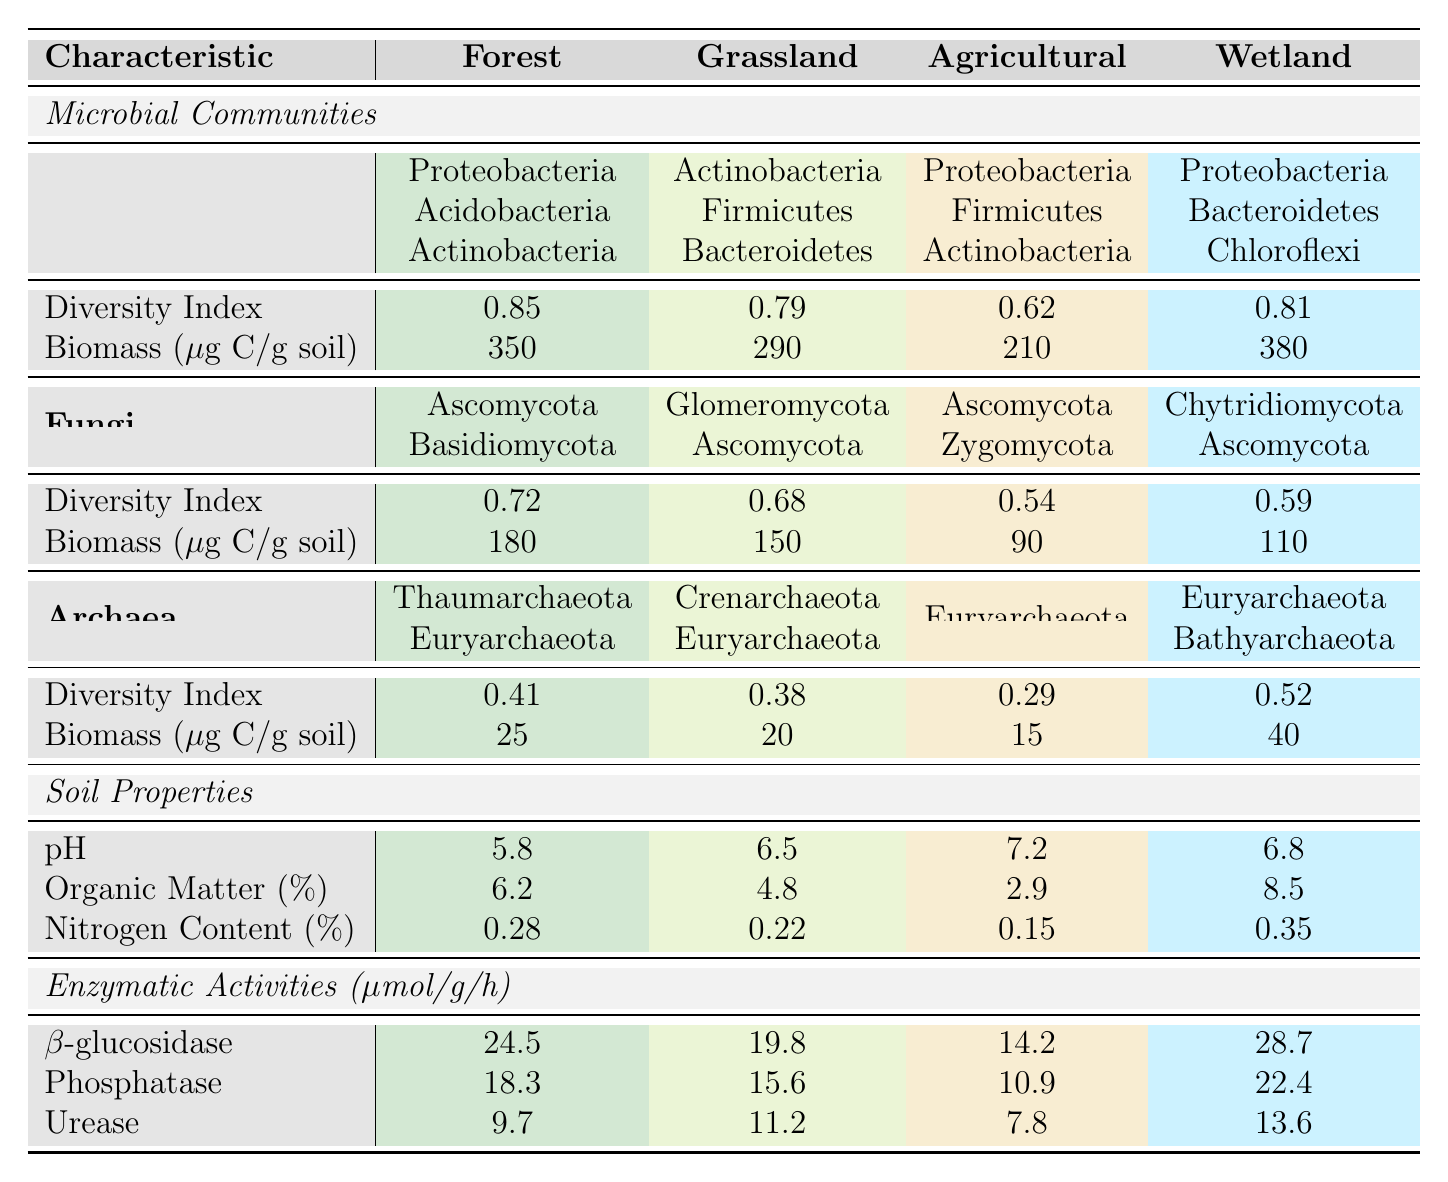What are the dominant bacterial phyla in forest land-use type? The table shows that the dominant bacterial phyla in the forest land-use type are Proteobacteria, Acidobacteria, and Actinobacteria.
Answer: Proteobacteria, Acidobacteria, Actinobacteria Which land-use type has the highest biomass of bacteria? In the table, the biomass for bacteria in various land-use types is shown. The forest has 350 μg C/g soil, grassland has 290 μg C/g soil, agricultural has 210 μg C/g soil, and wetland has 380 μg C/g soil. The wetland has the highest biomass of bacteria at 380 μg C/g soil.
Answer: Wetland What is the diversity index of fungi in agricultural land-use? Looking at the fungi section for agricultural land-use type, the diversity index is specified as 0.54.
Answer: 0.54 How does the average nitrogen content of forest land compare to that of agricultural land? The nitrogen content in forest land-use is 0.28% and in agricultural land-use is 0.15%. The average nitrogen content of forest land (0.28%) is higher than that of agricultural land (0.15%).
Answer: Higher What is the total enzymatic activity for β-glucosidase across all land-use types? The table provides the β-glucosidase activity as follows: Forest: 24.5; Grassland: 19.8; Agricultural: 14.2; Wetland: 28.7. Adding these values gives: 24.5 + 19.8 + 14.2 + 28.7 = 87.2 μmol/g/h.
Answer: 87.2 μmol/g/h Which land-use type has the lowest diversity index for archaea? The table indicates the diversity index for archaea: Forest: 0.41; Grassland: 0.38; Agricultural: 0.29; Wetland: 0.52. The agricultural land-use type has the lowest diversity index at 0.29.
Answer: Agricultural If we average the organic matter percentages across all land-use types, what is the result? The organic matter percentages are: Forest: 6.2%, Grassland: 4.8%, Agricultural: 2.9%, Wetland: 8.5%. Adding these gives a total of 6.2 + 4.8 + 2.9 + 8.5 = 22.4%. Dividing by 4 gives an average of 5.6%.
Answer: 5.6% Is the pH of grassland land-use type higher than that of wetland? The pH values from the table are: Forest: 5.8, Grassland: 6.5, Agricultural: 7.2, Wetland: 6.8. Comparing, the grassland (6.5) is not higher than the wetland (6.8). Therefore, the statement is false.
Answer: No What are the dominant fungal phyla in grassland? In the grassland land-use type, the dominant fungal phyla listed are Glomeromycota and Ascomycota, as per the table.
Answer: Glomeromycota, Ascomycota How much higher is the urease activity in wetland compared to agricultural land-use? Urease activities stated in the table are: Wetland: 13.6 μmol/g/h and Agricultural: 7.8 μmol/g/h. The difference is calculated as 13.6 - 7.8 = 5.8 μmol/g/h.
Answer: 5.8 μmol/g/h What is the average diversity index for bacteria across all land-use types? The diversity indices for bacteria are: Forest: 0.85, Grassland: 0.79, Agricultural: 0.62, Wetland: 0.81. Summing these gives 0.85 + 0.79 + 0.62 + 0.81 = 3.07. Dividing by 4 gives an average of 0.7675.
Answer: 0.7675 